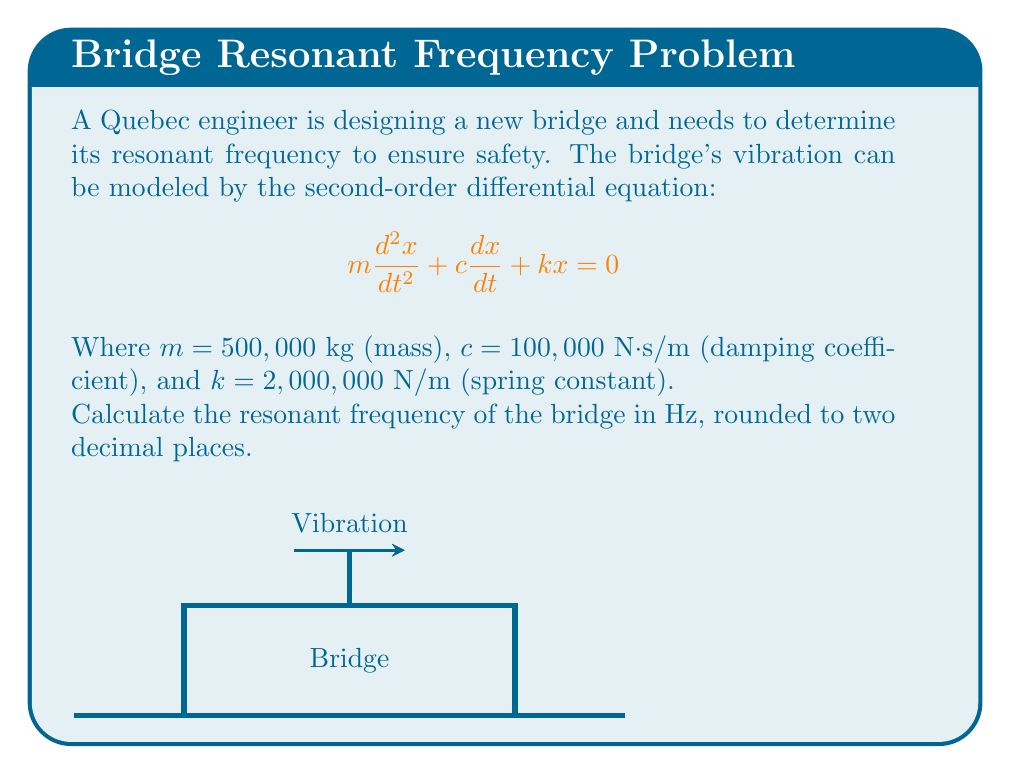Solve this math problem. To find the resonant frequency, we'll follow these steps:

1) The resonant frequency for an undamped system is given by:

   $$f_n = \frac{1}{2\pi}\sqrt{\frac{k}{m}}$$

2) However, our system is damped. For a damped system, we need to consider the damping ratio:

   $$\zeta = \frac{c}{2\sqrt{km}}$$

3) Let's calculate the damping ratio:

   $$\zeta = \frac{100,000}{2\sqrt{2,000,000 \cdot 500,000}} = 0.0707$$

4) Since $\zeta < 1$, this is an underdamped system. The damped natural frequency is:

   $$f_d = f_n\sqrt{1-\zeta^2}$$

5) First, let's calculate $f_n$:

   $$f_n = \frac{1}{2\pi}\sqrt{\frac{2,000,000}{500,000}} = 0.3183 \text{ Hz}$$

6) Now we can calculate $f_d$:

   $$f_d = 0.3183 \sqrt{1-0.0707^2} = 0.3173 \text{ Hz}$$

7) Rounding to two decimal places, we get 0.32 Hz.
Answer: 0.32 Hz 